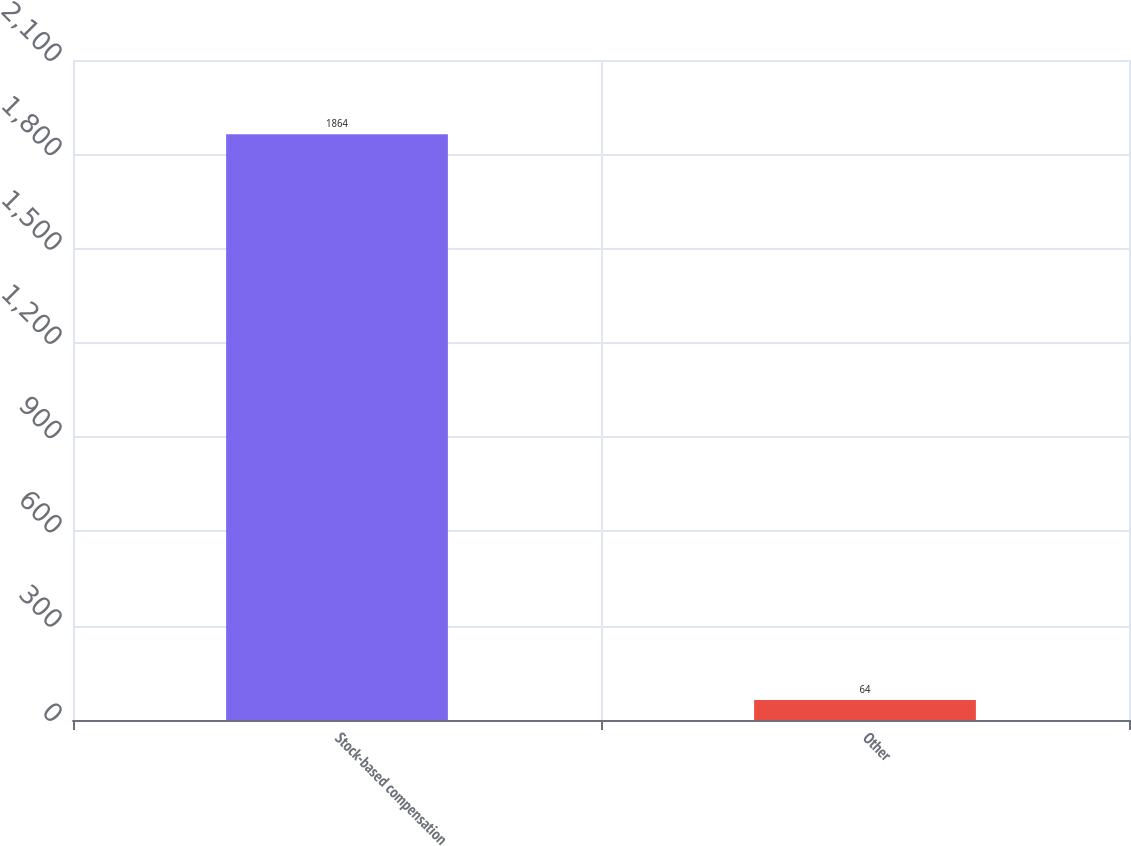Convert chart to OTSL. <chart><loc_0><loc_0><loc_500><loc_500><bar_chart><fcel>Stock-based compensation<fcel>Other<nl><fcel>1864<fcel>64<nl></chart> 